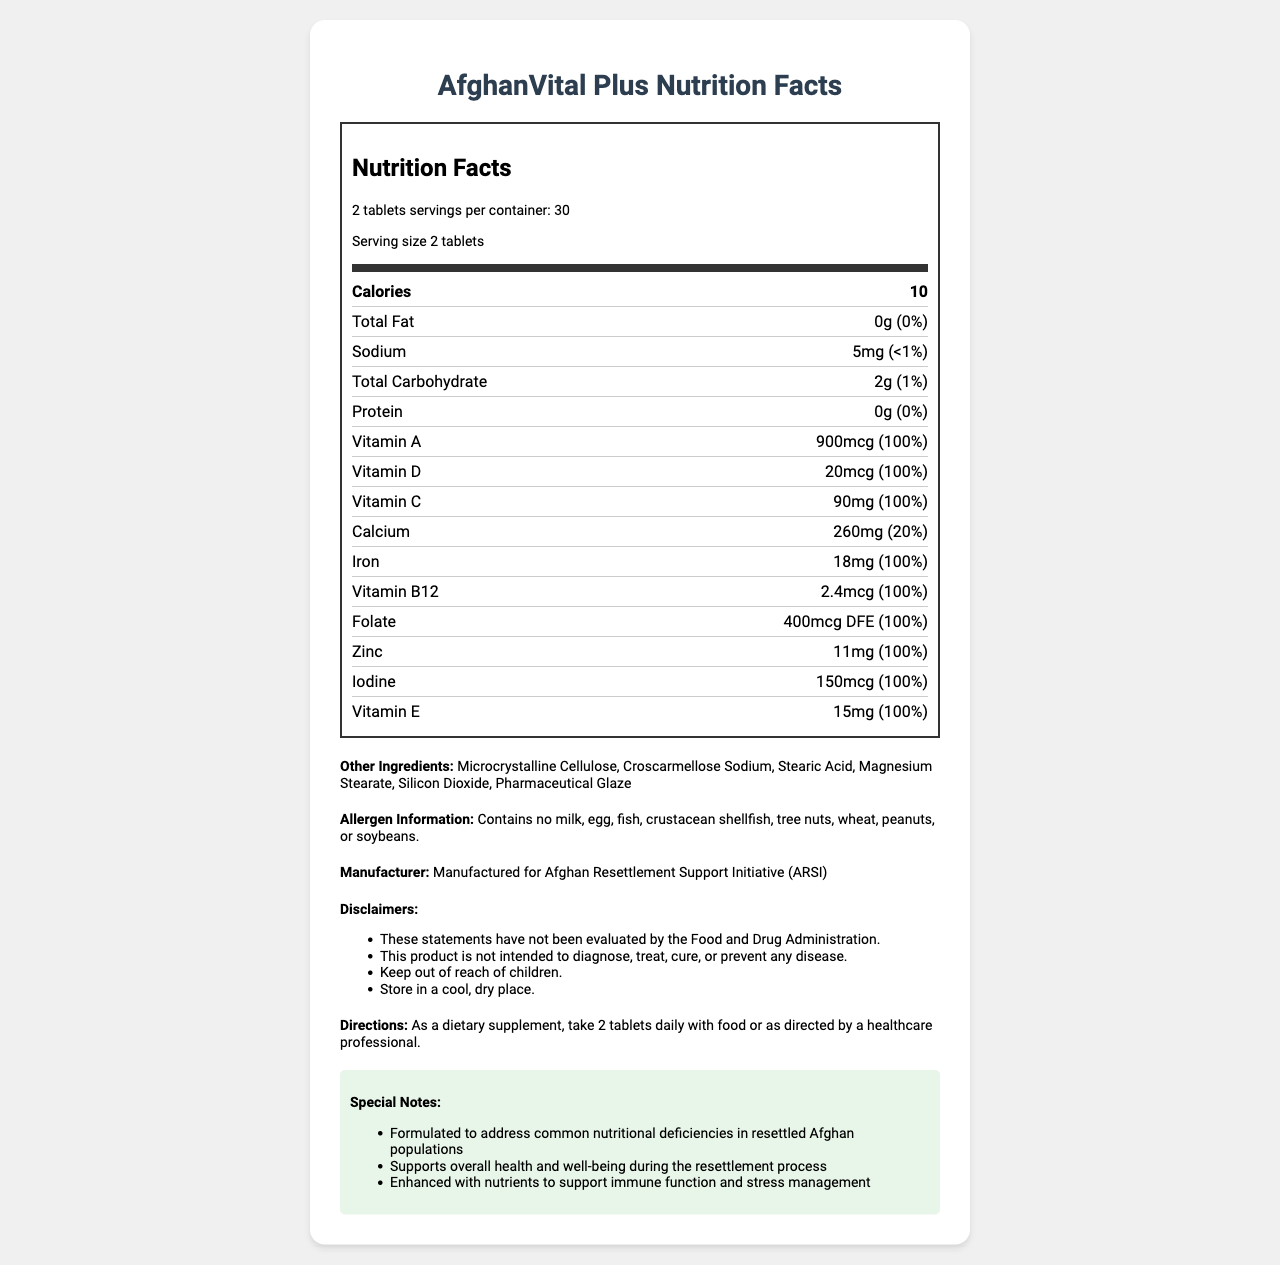What is the serving size for AfghanVital Plus? According to the document, the serving size for AfghanVital Plus is clearly stated as "2 tablets".
Answer: 2 tablets How many servings are there per container of AfghanVital Plus? The document specifies that there are 30 servings per container of AfghanVital Plus.
Answer: 30 How many calories are there per serving of AfghanVital Plus? The document mentions that there are 10 calories per serving.
Answer: 10 What is the amount of Vitamin D per serving? The document lists that each serving contains 20mcg of Vitamin D.
Answer: 20mcg Which nutrient has a daily value of 20% per serving? According to the document, Calcium has a daily value of 20% per serving.
Answer: Calcium How much Iron is there per serving? The document specifies that each serving contains 18mg of Iron.
Answer: 18mg Which of the following nutrients is not present in AfghanVital Plus? A. Total Fat B. Protein C. Vitamin B12 D. Sodium The document states that there is 0g of Total Fat per serving, indicating its absence.
Answer: A What is the daily value percentage of Vitamin A in one serving? A. 50% B. 75% C. 100% D. 150% According to the document, the daily value percentage for Vitamin A is 100% per serving.
Answer: C Does AfghanVital Plus contain any allergens such as milk, egg, or nuts? The document clearly states that AfghanVital Plus contains no allergens such as milk, egg, fish, crustacean shellfish, tree nuts, wheat, peanuts, or soybeans.
Answer: No What are the suggested directions for taking AfghanVital Plus? The document suggests taking 2 tablets daily with food or as directed by a healthcare professional.
Answer: Take 2 tablets daily with food or as directed by a healthcare professional Summarize the main purpose and nutritional benefits of AfghanVital Plus. The document describes AfghanVital Plus as a supplement targeted at addressing nutritional deficiencies commonly found in resettled Afghan populations, providing overall health benefits, and support for immune function and stress management.
Answer: AfghanVital Plus is a vitamin supplement formulated specifically to address common nutritional deficiencies in resettled Afghan populations. It supports overall health and well-being during the resettlement process and is enhanced with nutrients that support immune function and stress management. Who manufactures AfghanVital Plus? The document mentions that AfghanVital Plus is manufactured for the Afghan Resettlement Support Initiative (ARSI).
Answer: Afghan Resettlement Support Initiative (ARSI) What are the other ingredients in AfghanVital Plus? The document lists these ingredients under "Other Ingredients".
Answer: Microcrystalline Cellulose, Croscarmellose Sodium, Stearic Acid, Magnesium Stearate, Silicon Dioxide, Pharmaceutical Glaze Where should AfghanVital Plus be stored? The document advises storing AfghanVital Plus in a cool, dry place.
Answer: In a cool, dry place What are some key disclaimers associated with AfghanVital Plus? The document includes several disclaimers, such as the product not being evaluated by the FDA and its intended use, along with storage and safety directions.
Answer: The product has not been evaluated by the FDA, is not intended to diagnose, treat, cure, or prevent any disease, should be kept out of reach of children, and stored in a cool, dry place. Can AfghanVital Plus provide treatment for diseases? The document clearly states that this product is not intended to diagnose, treat, cure, or prevent any disease.
Answer: No Does the document give specific health conditions that AfghanVital Plus can manage or cure? The disclaimers in the document explicitly state that the product is not intended to diagnose, treat, cure, or prevent any disease, thus not listing any specific health conditions.
Answer: Not enough information 